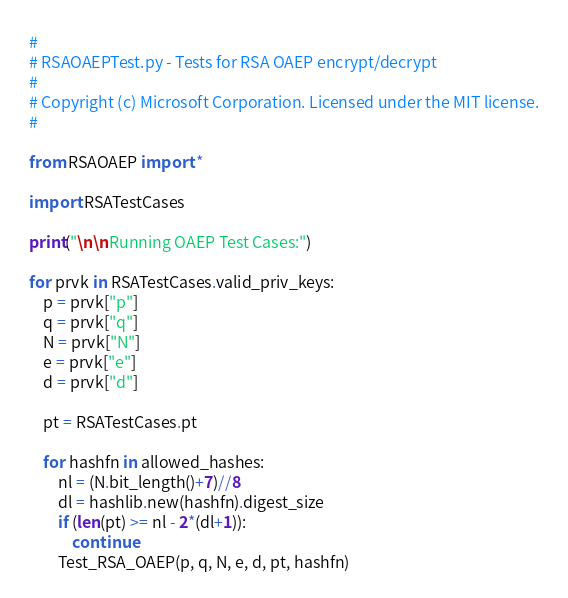Convert code to text. <code><loc_0><loc_0><loc_500><loc_500><_Python_>#
# RSAOAEPTest.py - Tests for RSA OAEP encrypt/decrypt
#
# Copyright (c) Microsoft Corporation. Licensed under the MIT license.
#

from RSAOAEP import *

import RSATestCases

print("\n\nRunning OAEP Test Cases:")

for prvk in RSATestCases.valid_priv_keys:
    p = prvk["p"]
    q = prvk["q"]
    N = prvk["N"]
    e = prvk["e"]
    d = prvk["d"]

    pt = RSATestCases.pt

    for hashfn in allowed_hashes:
        nl = (N.bit_length()+7)//8
        dl = hashlib.new(hashfn).digest_size
        if (len(pt) >= nl - 2*(dl+1)):
            continue
        Test_RSA_OAEP(p, q, N, e, d, pt, hashfn)
</code> 